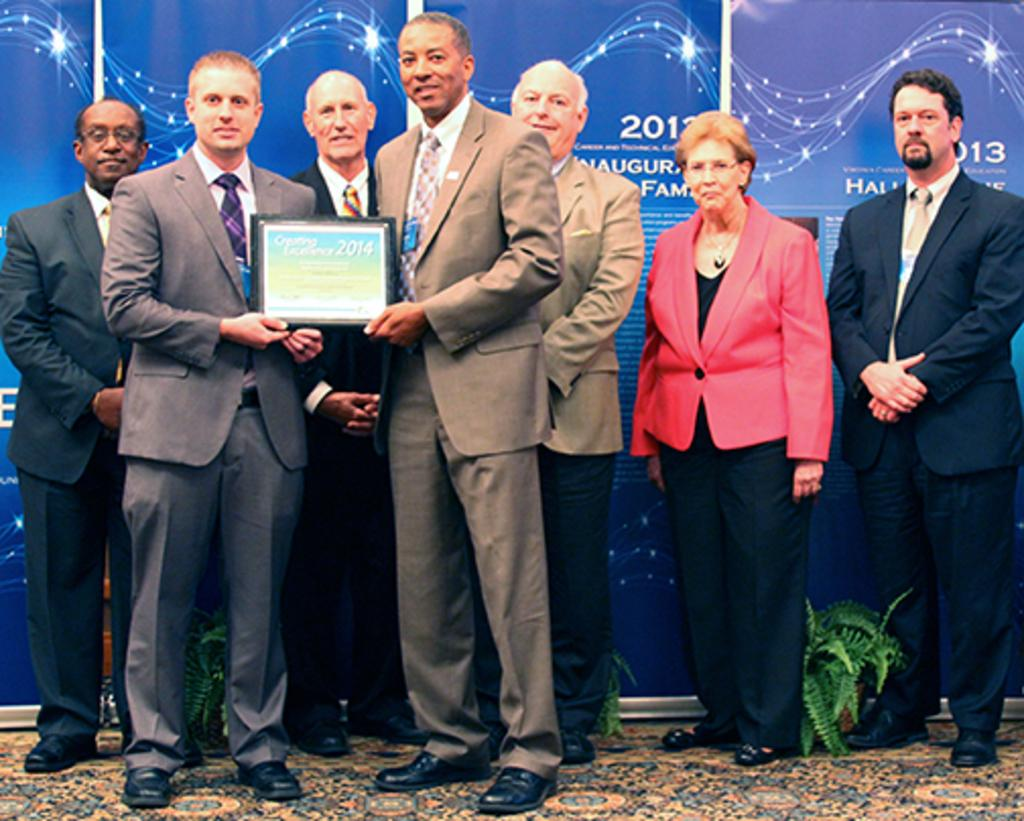How many people are in the image? There is a group of people in the image. What are two persons holding in the image? Two persons are holding a certificate. What can be seen behind the people in the image? There are boards visible behind the people. What type of plants are on the floor in the image? House plants are present on the floor. What type of toy can be seen in the hands of the person holding the certificate? There is no toy present in the image; the two persons are holding a certificate. 